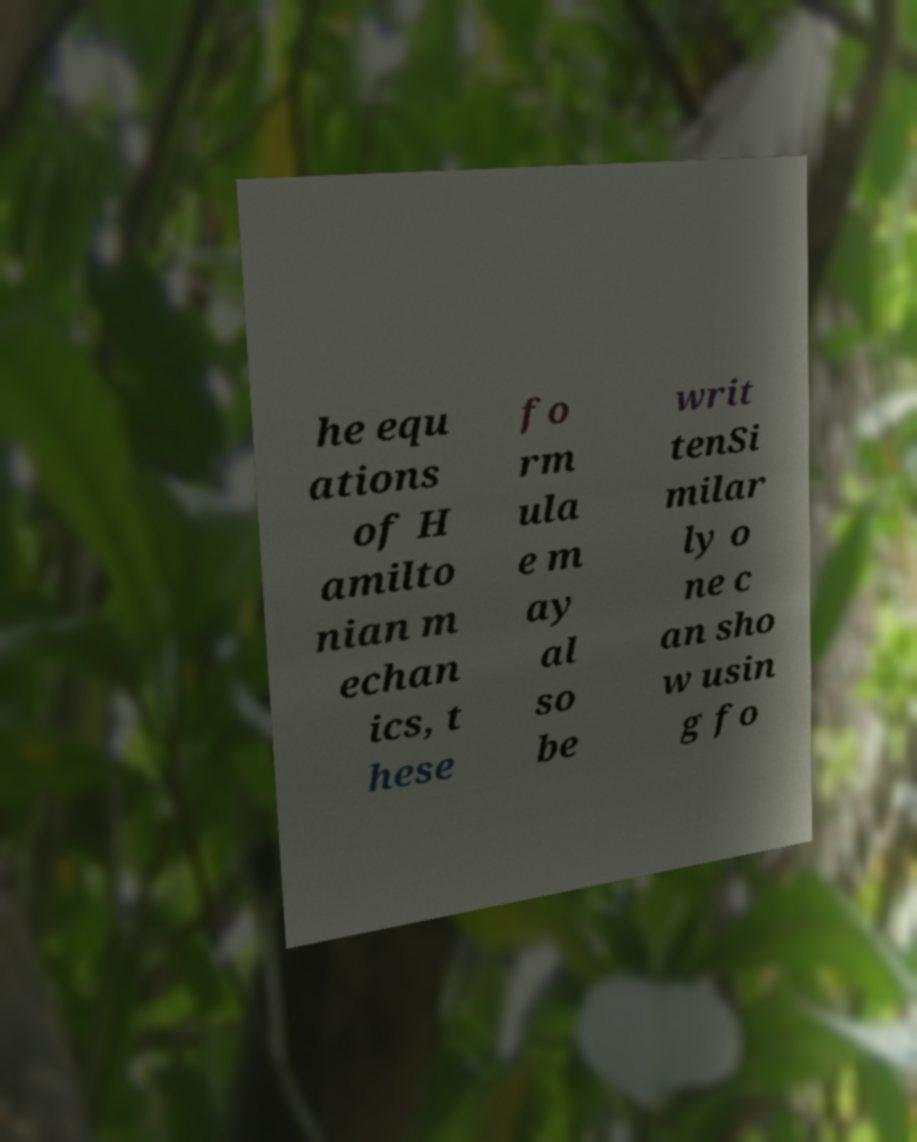For documentation purposes, I need the text within this image transcribed. Could you provide that? he equ ations of H amilto nian m echan ics, t hese fo rm ula e m ay al so be writ tenSi milar ly o ne c an sho w usin g fo 